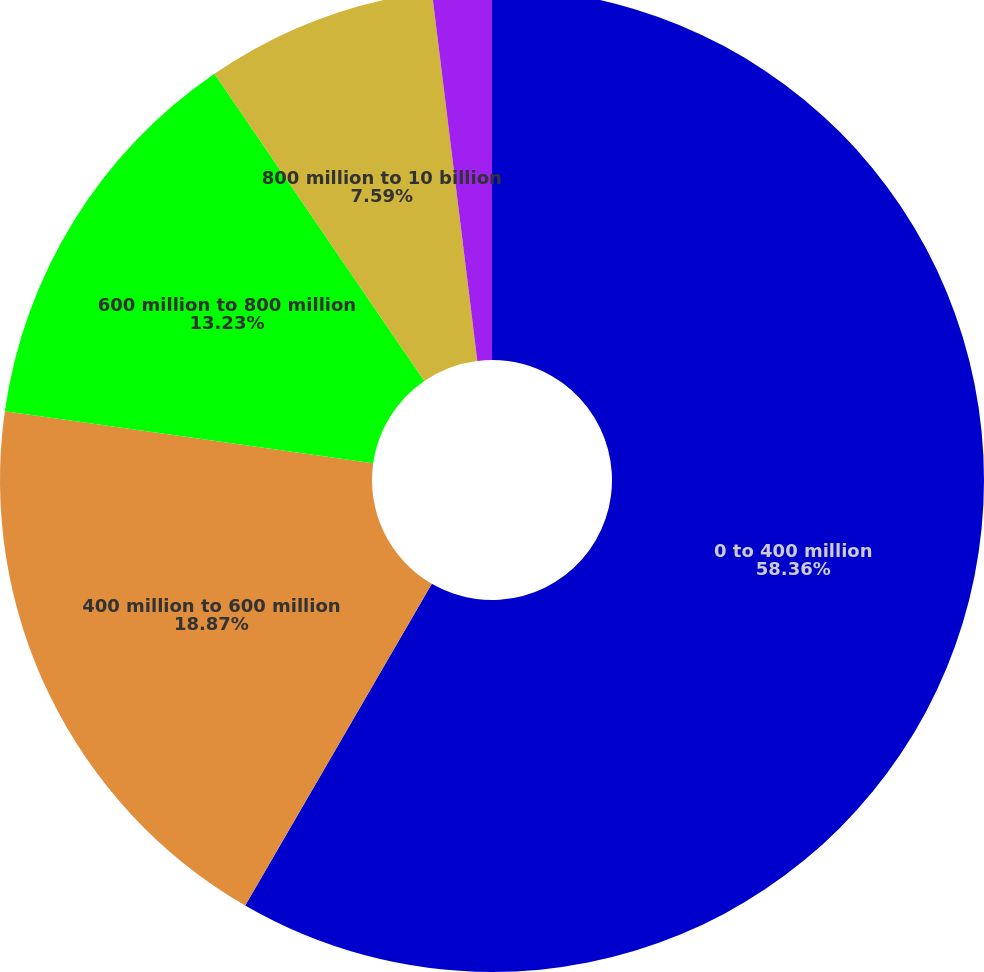<chart> <loc_0><loc_0><loc_500><loc_500><pie_chart><fcel>0 to 400 million<fcel>400 million to 600 million<fcel>600 million to 800 million<fcel>800 million to 10 billion<fcel>In excess of 10 billion<nl><fcel>58.37%<fcel>18.87%<fcel>13.23%<fcel>7.59%<fcel>1.95%<nl></chart> 